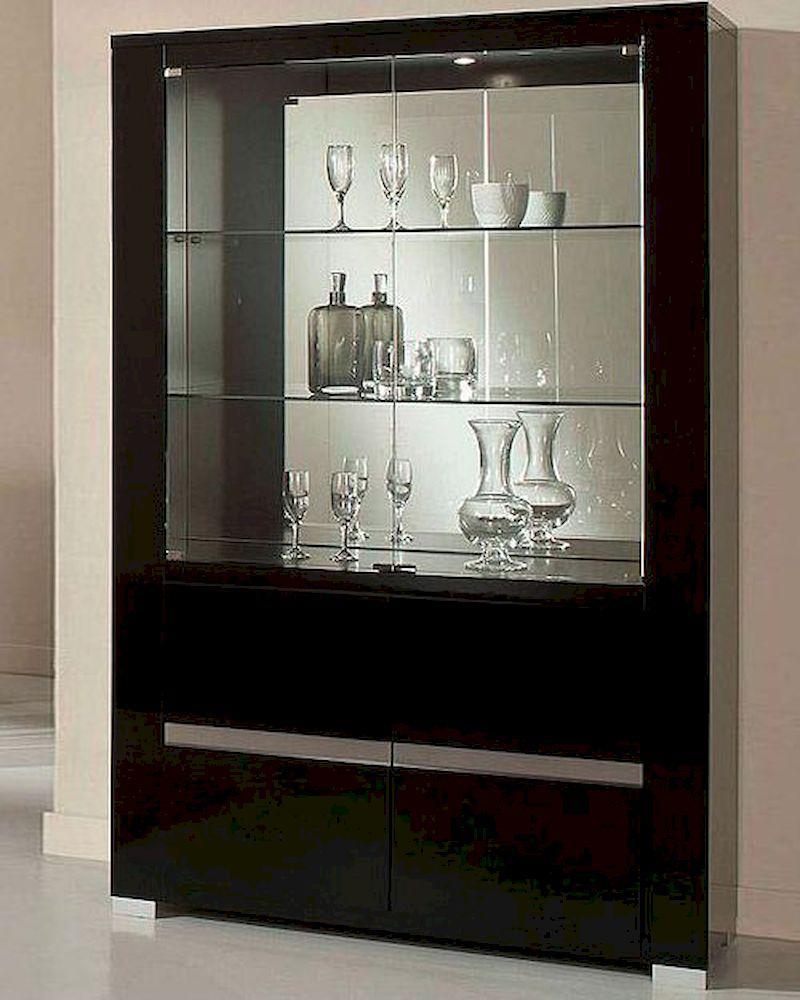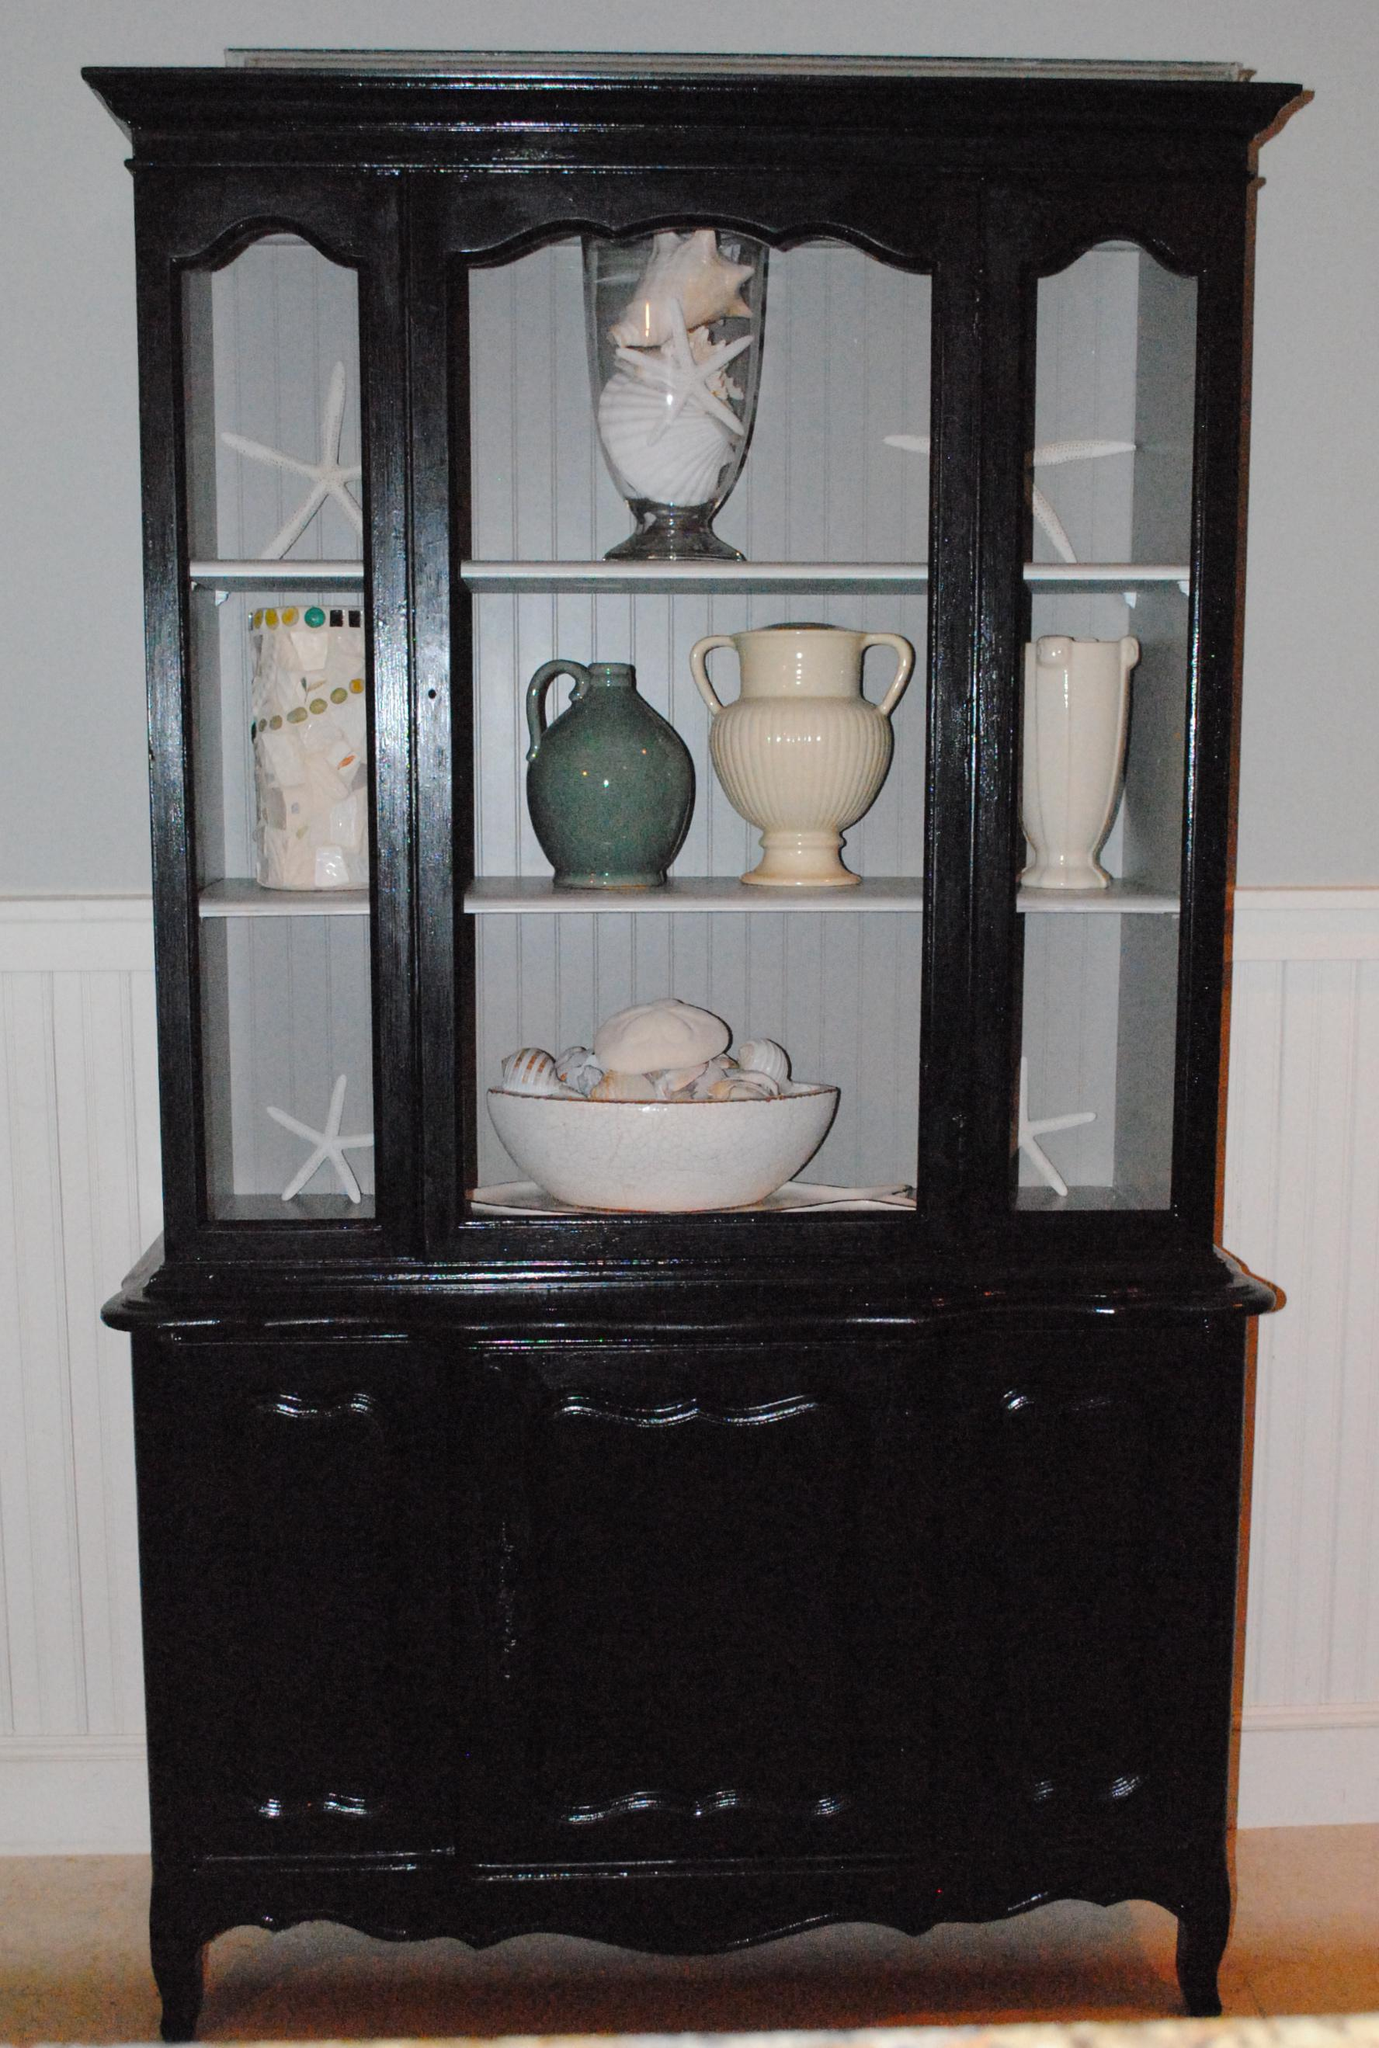The first image is the image on the left, the second image is the image on the right. For the images displayed, is the sentence "There is at least one item on top of the cabinet in the image on the left." factually correct? Answer yes or no. No. 